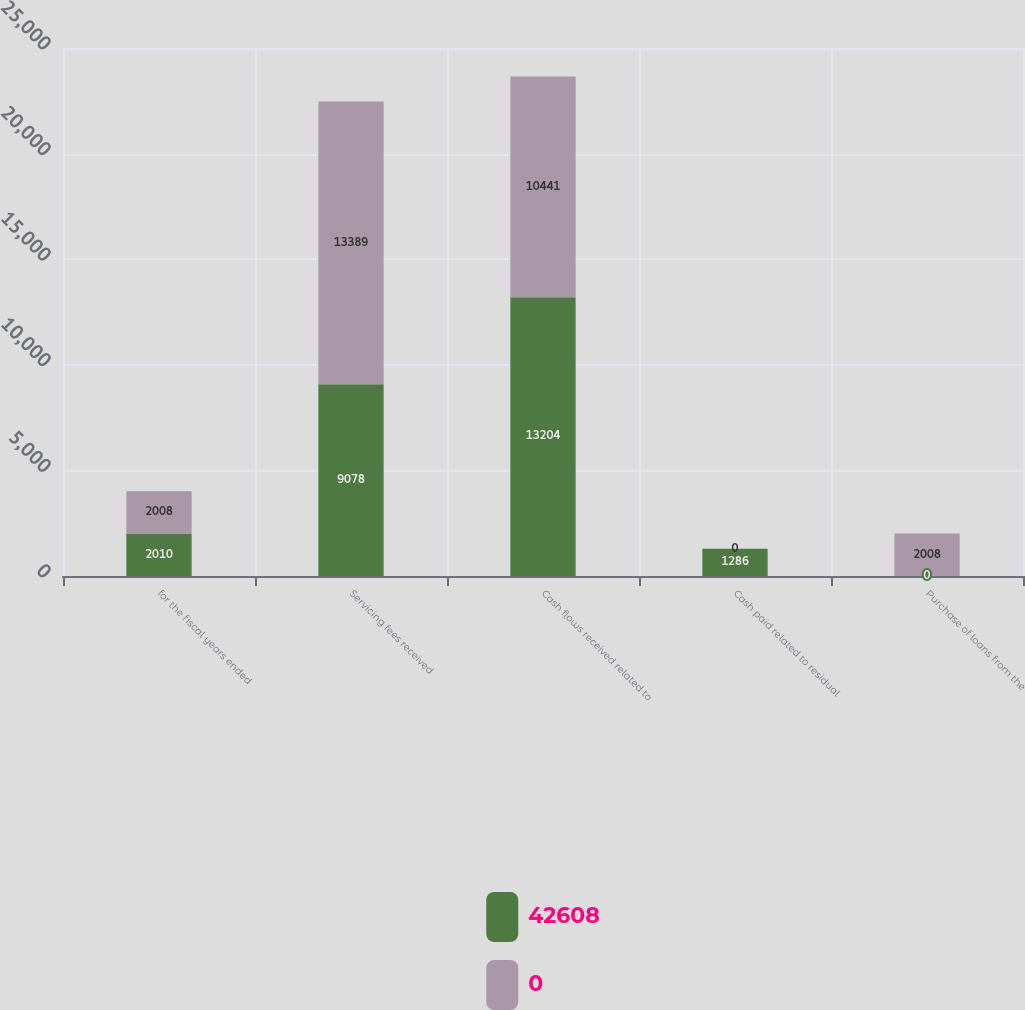<chart> <loc_0><loc_0><loc_500><loc_500><stacked_bar_chart><ecel><fcel>for the fiscal years ended<fcel>Servicing fees received<fcel>Cash flows received related to<fcel>Cash paid related to residual<fcel>Purchase of loans from the<nl><fcel>42608<fcel>2010<fcel>9078<fcel>13204<fcel>1286<fcel>0<nl><fcel>0<fcel>2008<fcel>13389<fcel>10441<fcel>0<fcel>2008<nl></chart> 